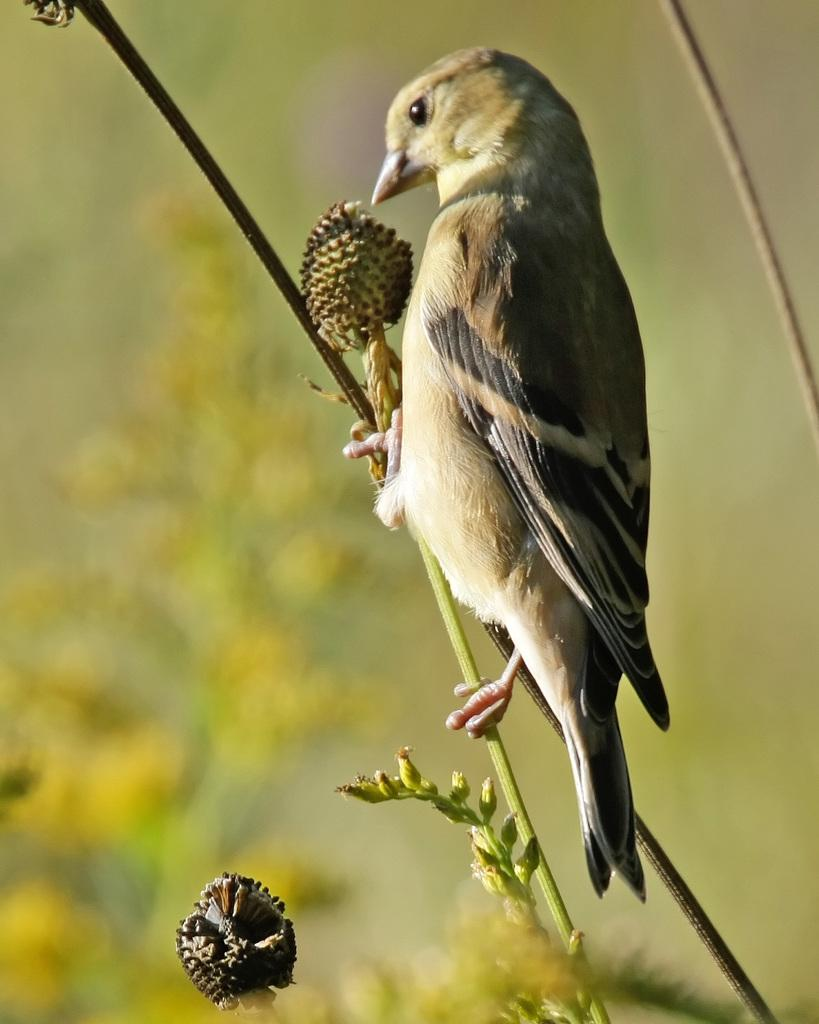What type of animal can be seen in the image? There is a bird in the image. Where is the bird located in the image? The bird is sitting on a plant stem. Can you describe the background of the image? The background of the image is blurred. What is the value of the bird's fight in the image? There is no fight or value associated with the bird in the image; it is simply sitting on a plant stem. 